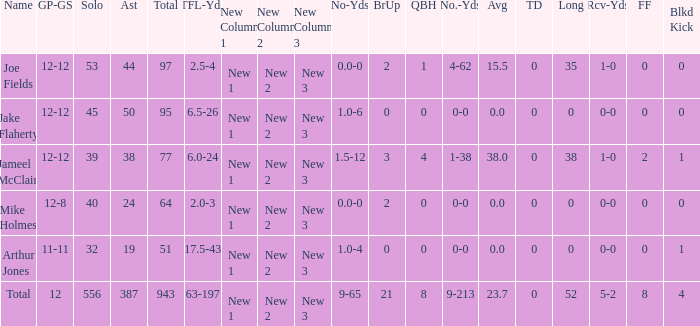I'm looking to parse the entire table for insights. Could you assist me with that? {'header': ['Name', 'GP-GS', 'Solo', 'Ast', 'Total', 'TFL-Yds', 'New Column 1', 'New Column 2', 'New Column 3', 'No-Yds', 'BrUp', 'QBH', 'No.-Yds', 'Avg', 'TD', 'Long', 'Rcv-Yds', 'FF', 'Blkd Kick'], 'rows': [['Joe Fields', '12-12', '53', '44', '97', '2.5-4', 'New 1', 'New 2', 'New 3', '0.0-0', '2', '1', '4-62', '15.5', '0', '35', '1-0', '0', '0'], ['Jake Flaherty', '12-12', '45', '50', '95', '6.5-26', 'New 1', 'New 2', 'New 3', '1.0-6', '0', '0', '0-0', '0.0', '0', '0', '0-0', '0', '0'], ['Jameel McClain', '12-12', '39', '38', '77', '6.0-24', 'New 1', 'New 2', 'New 3', '1.5-12', '3', '4', '1-38', '38.0', '0', '38', '1-0', '2', '1'], ['Mike Holmes', '12-8', '40', '24', '64', '2.0-3', 'New 1', 'New 2', 'New 3', '0.0-0', '2', '0', '0-0', '0.0', '0', '0', '0-0', '0', '0'], ['Arthur Jones', '11-11', '32', '19', '51', '17.5-43', 'New 1', 'New 2', 'New 3', '1.0-4', '0', '0', '0-0', '0.0', '0', '0', '0-0', '0', '1'], ['Total', '12', '556', '387', '943', '63-197', 'New 1', 'New 2', 'New 3', '9-65', '21', '8', '9-213', '23.7', '0', '52', '5-2', '8', '4']]} How many yards for the player with tfl-yds of 2.5-4? 4-62. 